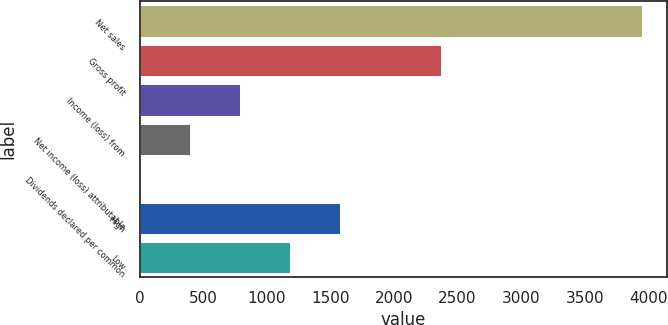Convert chart to OTSL. <chart><loc_0><loc_0><loc_500><loc_500><bar_chart><fcel>Net sales<fcel>Gross profit<fcel>Income (loss) from<fcel>Net income (loss) attributable<fcel>Dividends declared per common<fcel>High<fcel>Low<nl><fcel>3947.3<fcel>2368.49<fcel>789.66<fcel>394.96<fcel>0.25<fcel>1579.07<fcel>1184.37<nl></chart> 